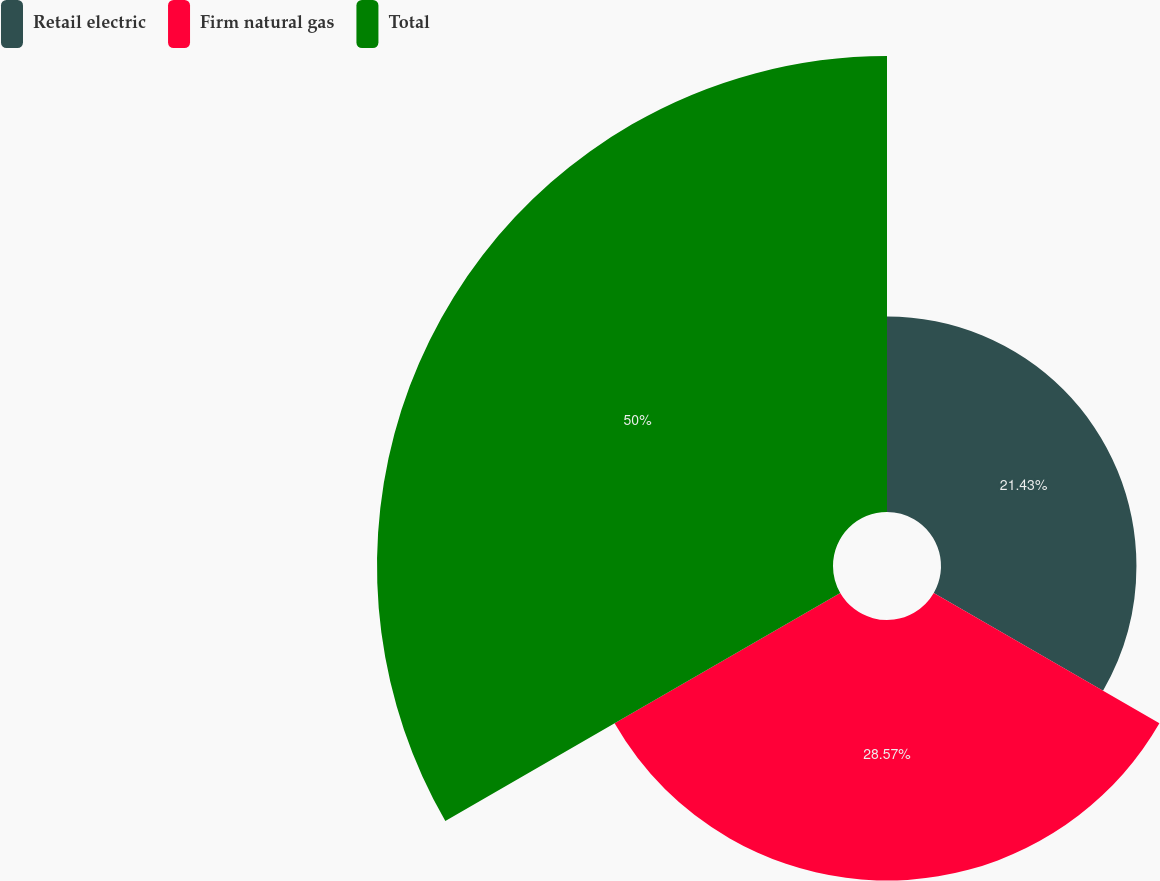Convert chart. <chart><loc_0><loc_0><loc_500><loc_500><pie_chart><fcel>Retail electric<fcel>Firm natural gas<fcel>Total<nl><fcel>21.43%<fcel>28.57%<fcel>50.0%<nl></chart> 